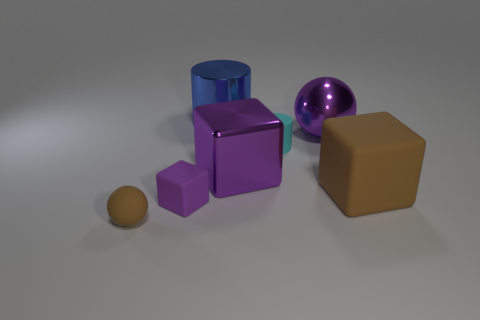Add 2 blue matte balls. How many objects exist? 9 Subtract all blocks. How many objects are left? 4 Add 2 small balls. How many small balls are left? 3 Add 7 small rubber spheres. How many small rubber spheres exist? 8 Subtract 0 red blocks. How many objects are left? 7 Subtract all large yellow blocks. Subtract all large purple blocks. How many objects are left? 6 